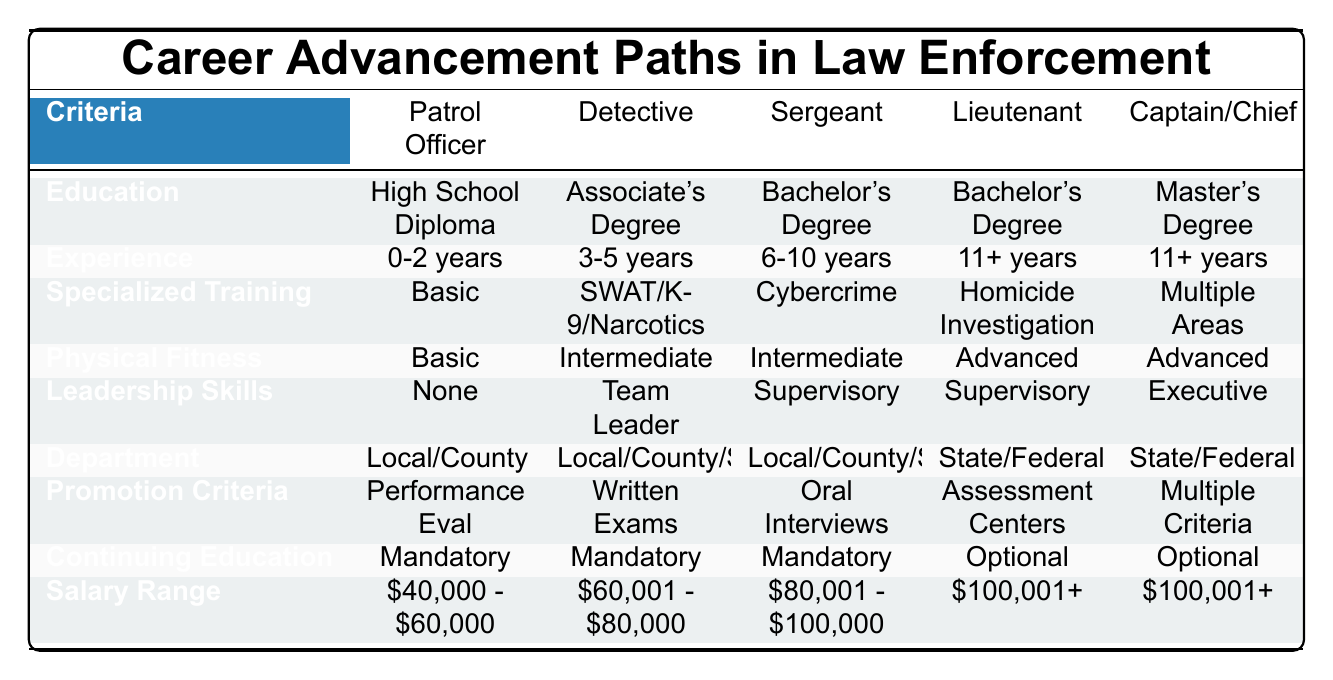What is the education requirement for a Detective? The education requirement for a Detective is an Associate's Degree, as indicated in the second column under the Education row.
Answer: Associate's Degree How many years of experience are required for a Captain? A Captain requires 11+ years of experience, as shown in the Experience row of the table in the Captain column.
Answer: 11+ years Is continuing education mandatory for a Patrol Officer? Yes, continuing education is mandatory for a Patrol Officer, as listed in the Continuing Education row associated with the Patrol Officer column.
Answer: Yes What is the highest salary range listed for any position? The highest salary range is $100,001+, which appears in the Salary Range row under both the Captain and Chief of Police columns.
Answer: $100,001+ How does the physical fitness requirement change from a Patrol Officer to a Lieutenant? The physical fitness requirement increases from Basic for a Patrol Officer to Advanced for a Lieutenant, indicating a higher standard needed for advancement.
Answer: It increases from Basic to Advanced Which positions require specialized training in multiple areas? Only the Captain/Chief position requires specialized training in multiple areas, as noted in the Specialized Training row.
Answer: Captain/Chief Is there a requirement for leadership skills for the position of Sergeant? Yes, the position of Sergeant requires Supervisory skills, as mentioned in the Leadership Skills row related to the Sergeant column.
Answer: Yes What is the common department for a Detective and a Sergeant? Both Detective and Sergeant positions are associated with Local and County Departments, as indicated in the Department row for those positions.
Answer: Local and County Departments Calculate the average salary range for all positions listed in the table. The salary ranges are as follows: $50,000 (average of $40,000 - $60,000), $70,000 (average of $60,001 - $80,000), $90,000 (average of $80,001 - $100,000), $100,001 (lower bound for $100,001+). The average is calculated as (50,000 + 70,000 + 90,000 + 100,001)/4 = 77,500.25, so it can be approximated to $77,500.
Answer: $77,500 